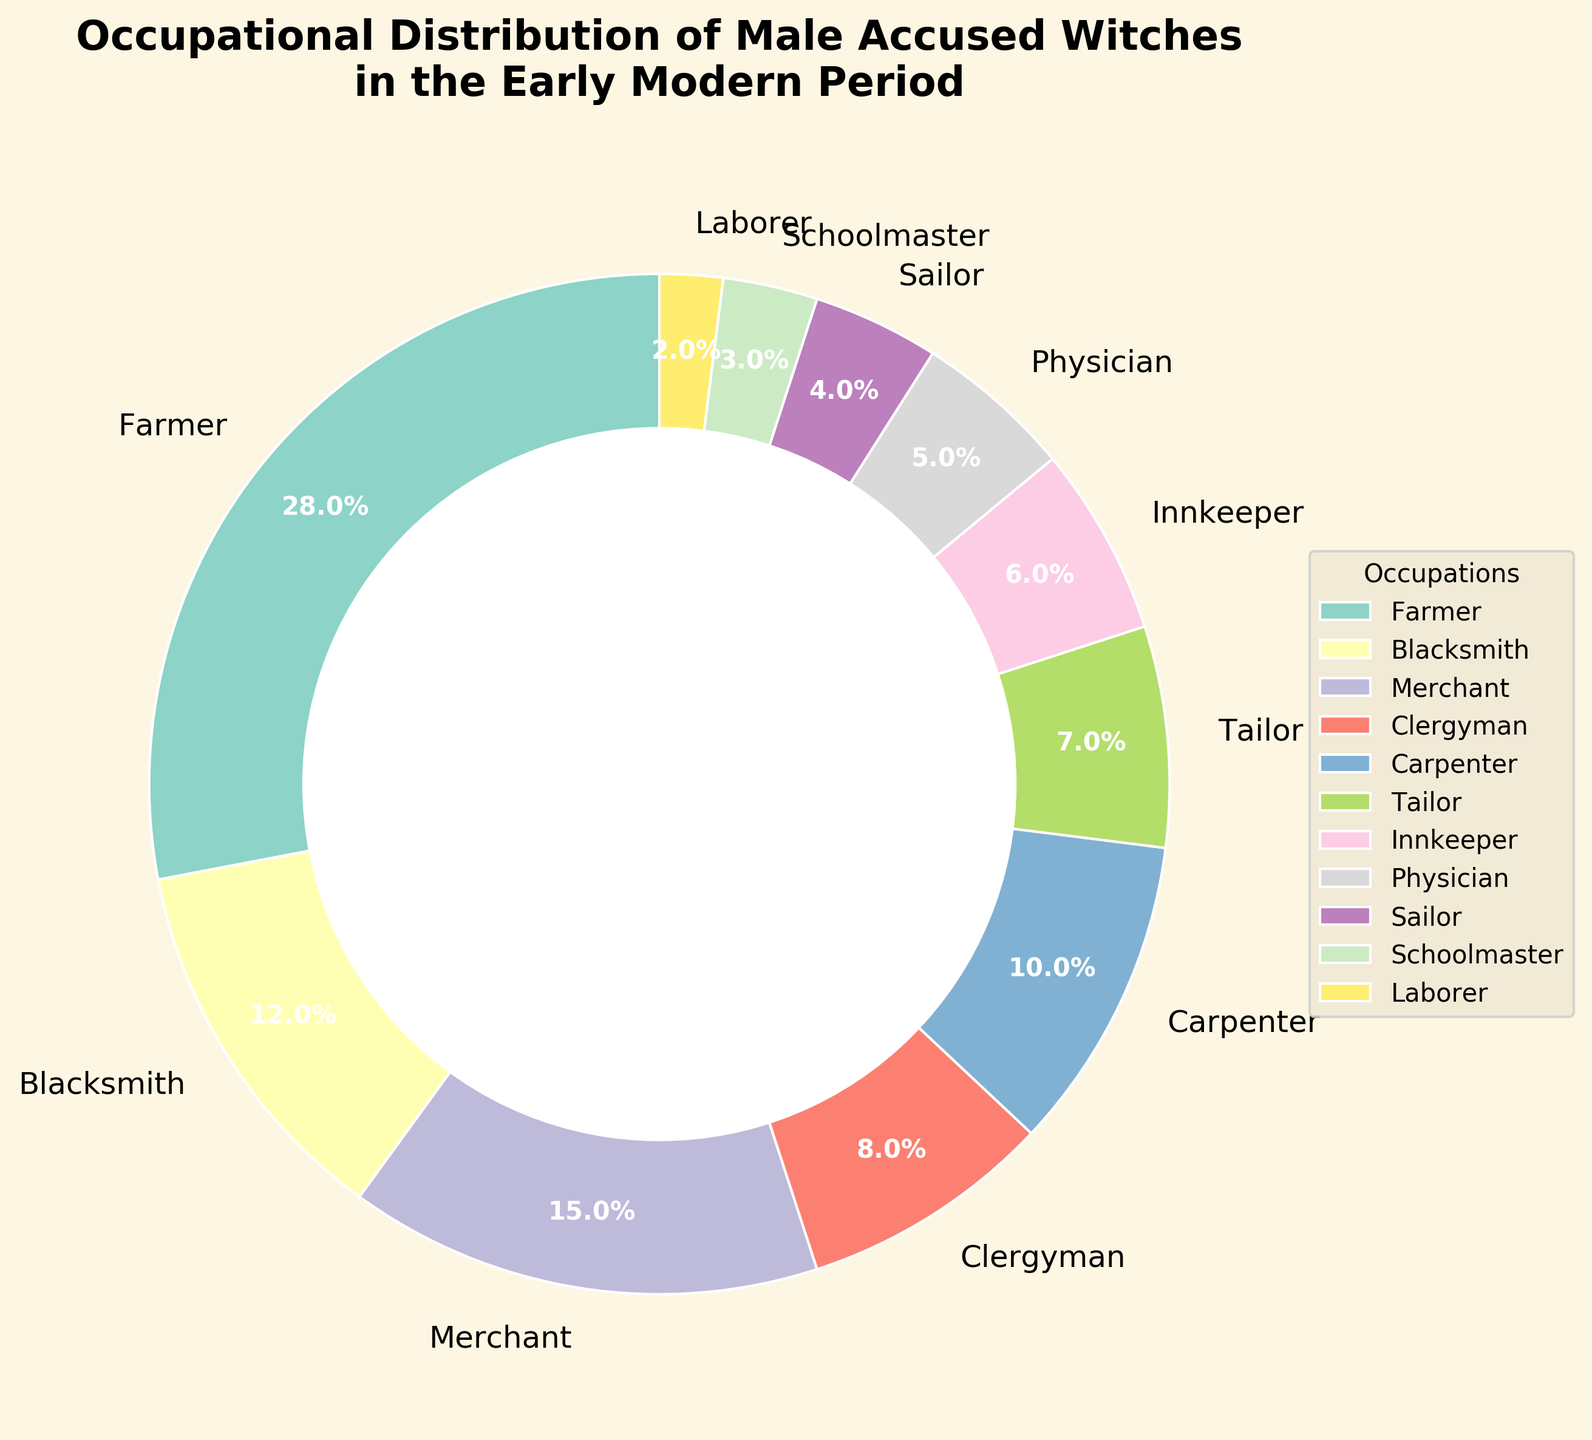Which occupation has the highest percentage of male accused witches? The pie chart shows different occupations with their corresponding percentages. The largest wedge indicates the highest percentage. The "Farmer" occupation has the largest wedge at 28%.
Answer: Farmer What is the combined percentage of male accused witches who were either blacksmiths or carpenters? Sum the percentages of blacksmiths and carpenters: 12% (blacksmith) + 10% (carpenter) = 22%.
Answer: 22% Which two occupations have the smallest percentages, and what are their combined values? The smallest wedges on the pie chart are labeled "Laborer" (2%) and "Schoolmaster" (3%). Their combined value is 2% + 3% = 5%.
Answer: Laborer and Schoolmaster, 5% Is the percentage of male accused witches who were tailors greater than those who were physicians? Compare the percentages: Tailors are 7%, and Physicians are 5%. Since 7% > 5%, the tailors' percentage is greater.
Answer: Yes What is the percentage difference between merchants and sailors? Subtract the smaller percentage from the larger one: 15% (merchants) - 4% (sailors) = 11%.
Answer: 11% Based on the pie chart, which occupation category is visually distinct with a unique placement in the chart? Notice the distinct placement of the largest wedge (Farmer) at the left of the pie chart when viewed from the top. Its unique position and large size make it visually distinct.
Answer: Farmer What percentage of male accused witches worked in occupations related to direct physical labor (farmer, laborer, carpenter)? Sum the percentages of farmers, laborers, and carpenters: 28% (farmer) + 2% (laborer) + 10% (carpenter) = 40%.
Answer: 40% If you combine the percentages of clergymen, innkeepers, and schoolmasters, does it exceed the percentage of farmers? Sum the percentages of clergymen, innkeepers, and schoolmasters: 8% (clergyman) + 6% (innkeeper) + 3% (schoolmaster) = 17%. This does not exceed 28% (farmers).
Answer: No What is the average percentage of male accused witches across all listed occupations? Sum all listed percentages and divide by the number of occupations: (28 + 12 + 15 + 8 + 10 + 7 + 6 + 5 + 4 + 3 + 2) / 11 = 100 / 11 ≈ 9.09%.
Answer: 9.09% Which occupations have a percentage that falls below the pie chart's median value, and what are they? To find the median value of the percentages, list them in ascending order: 2, 3, 4, 5, 6, 7, 8, 10, 12, 15, 28. The median is the 6th value: 7%. Occupations below this value are laborer (2%), schoolmaster (3%), sailor (4%), and physician (5%).
Answer: Laborer, Schoolmaster, Sailor, Physician 